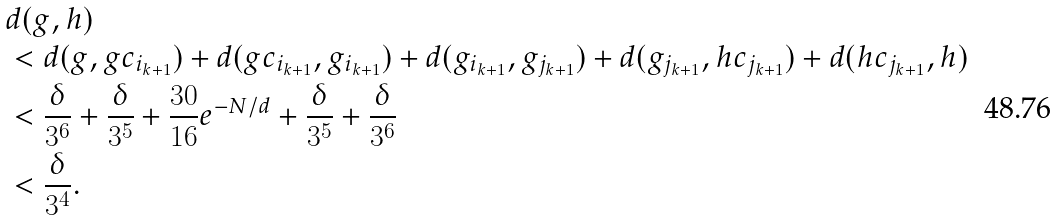Convert formula to latex. <formula><loc_0><loc_0><loc_500><loc_500>& d ( g , h ) \\ & < d ( g , g c _ { i _ { k + 1 } } ) + d ( g c _ { i _ { k + 1 } } , g _ { i _ { k + 1 } } ) + d ( g _ { i _ { k + 1 } } , g _ { j _ { k + 1 } } ) + d ( g _ { j _ { k + 1 } } , h c _ { j _ { k + 1 } } ) + d ( h c _ { j _ { k + 1 } } , h ) \\ & < \frac { \delta } { 3 ^ { 6 } } + \frac { \delta } { 3 ^ { 5 } } + \frac { 3 0 } { 1 6 } e ^ { - N / d } + \frac { \delta } { 3 ^ { 5 } } + \frac { \delta } { 3 ^ { 6 } } \\ & < \frac { \delta } { 3 ^ { 4 } } .</formula> 